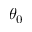Convert formula to latex. <formula><loc_0><loc_0><loc_500><loc_500>\theta _ { 0 }</formula> 